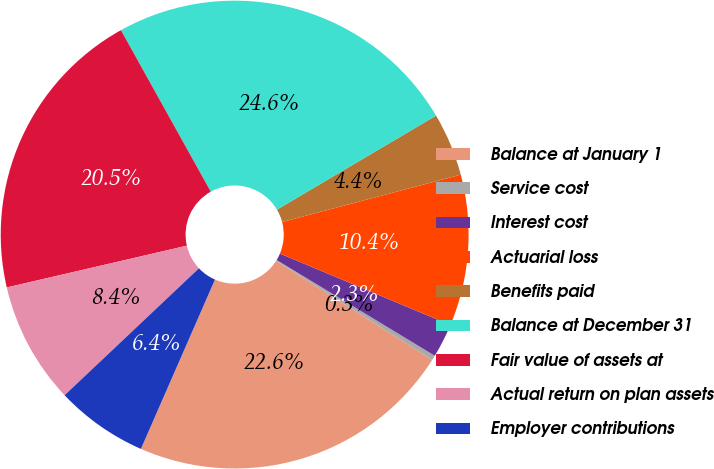Convert chart to OTSL. <chart><loc_0><loc_0><loc_500><loc_500><pie_chart><fcel>Balance at January 1<fcel>Service cost<fcel>Interest cost<fcel>Actuarial loss<fcel>Benefits paid<fcel>Balance at December 31<fcel>Fair value of assets at<fcel>Actual return on plan assets<fcel>Employer contributions<nl><fcel>22.57%<fcel>0.33%<fcel>2.35%<fcel>10.44%<fcel>4.37%<fcel>24.59%<fcel>20.55%<fcel>8.42%<fcel>6.39%<nl></chart> 